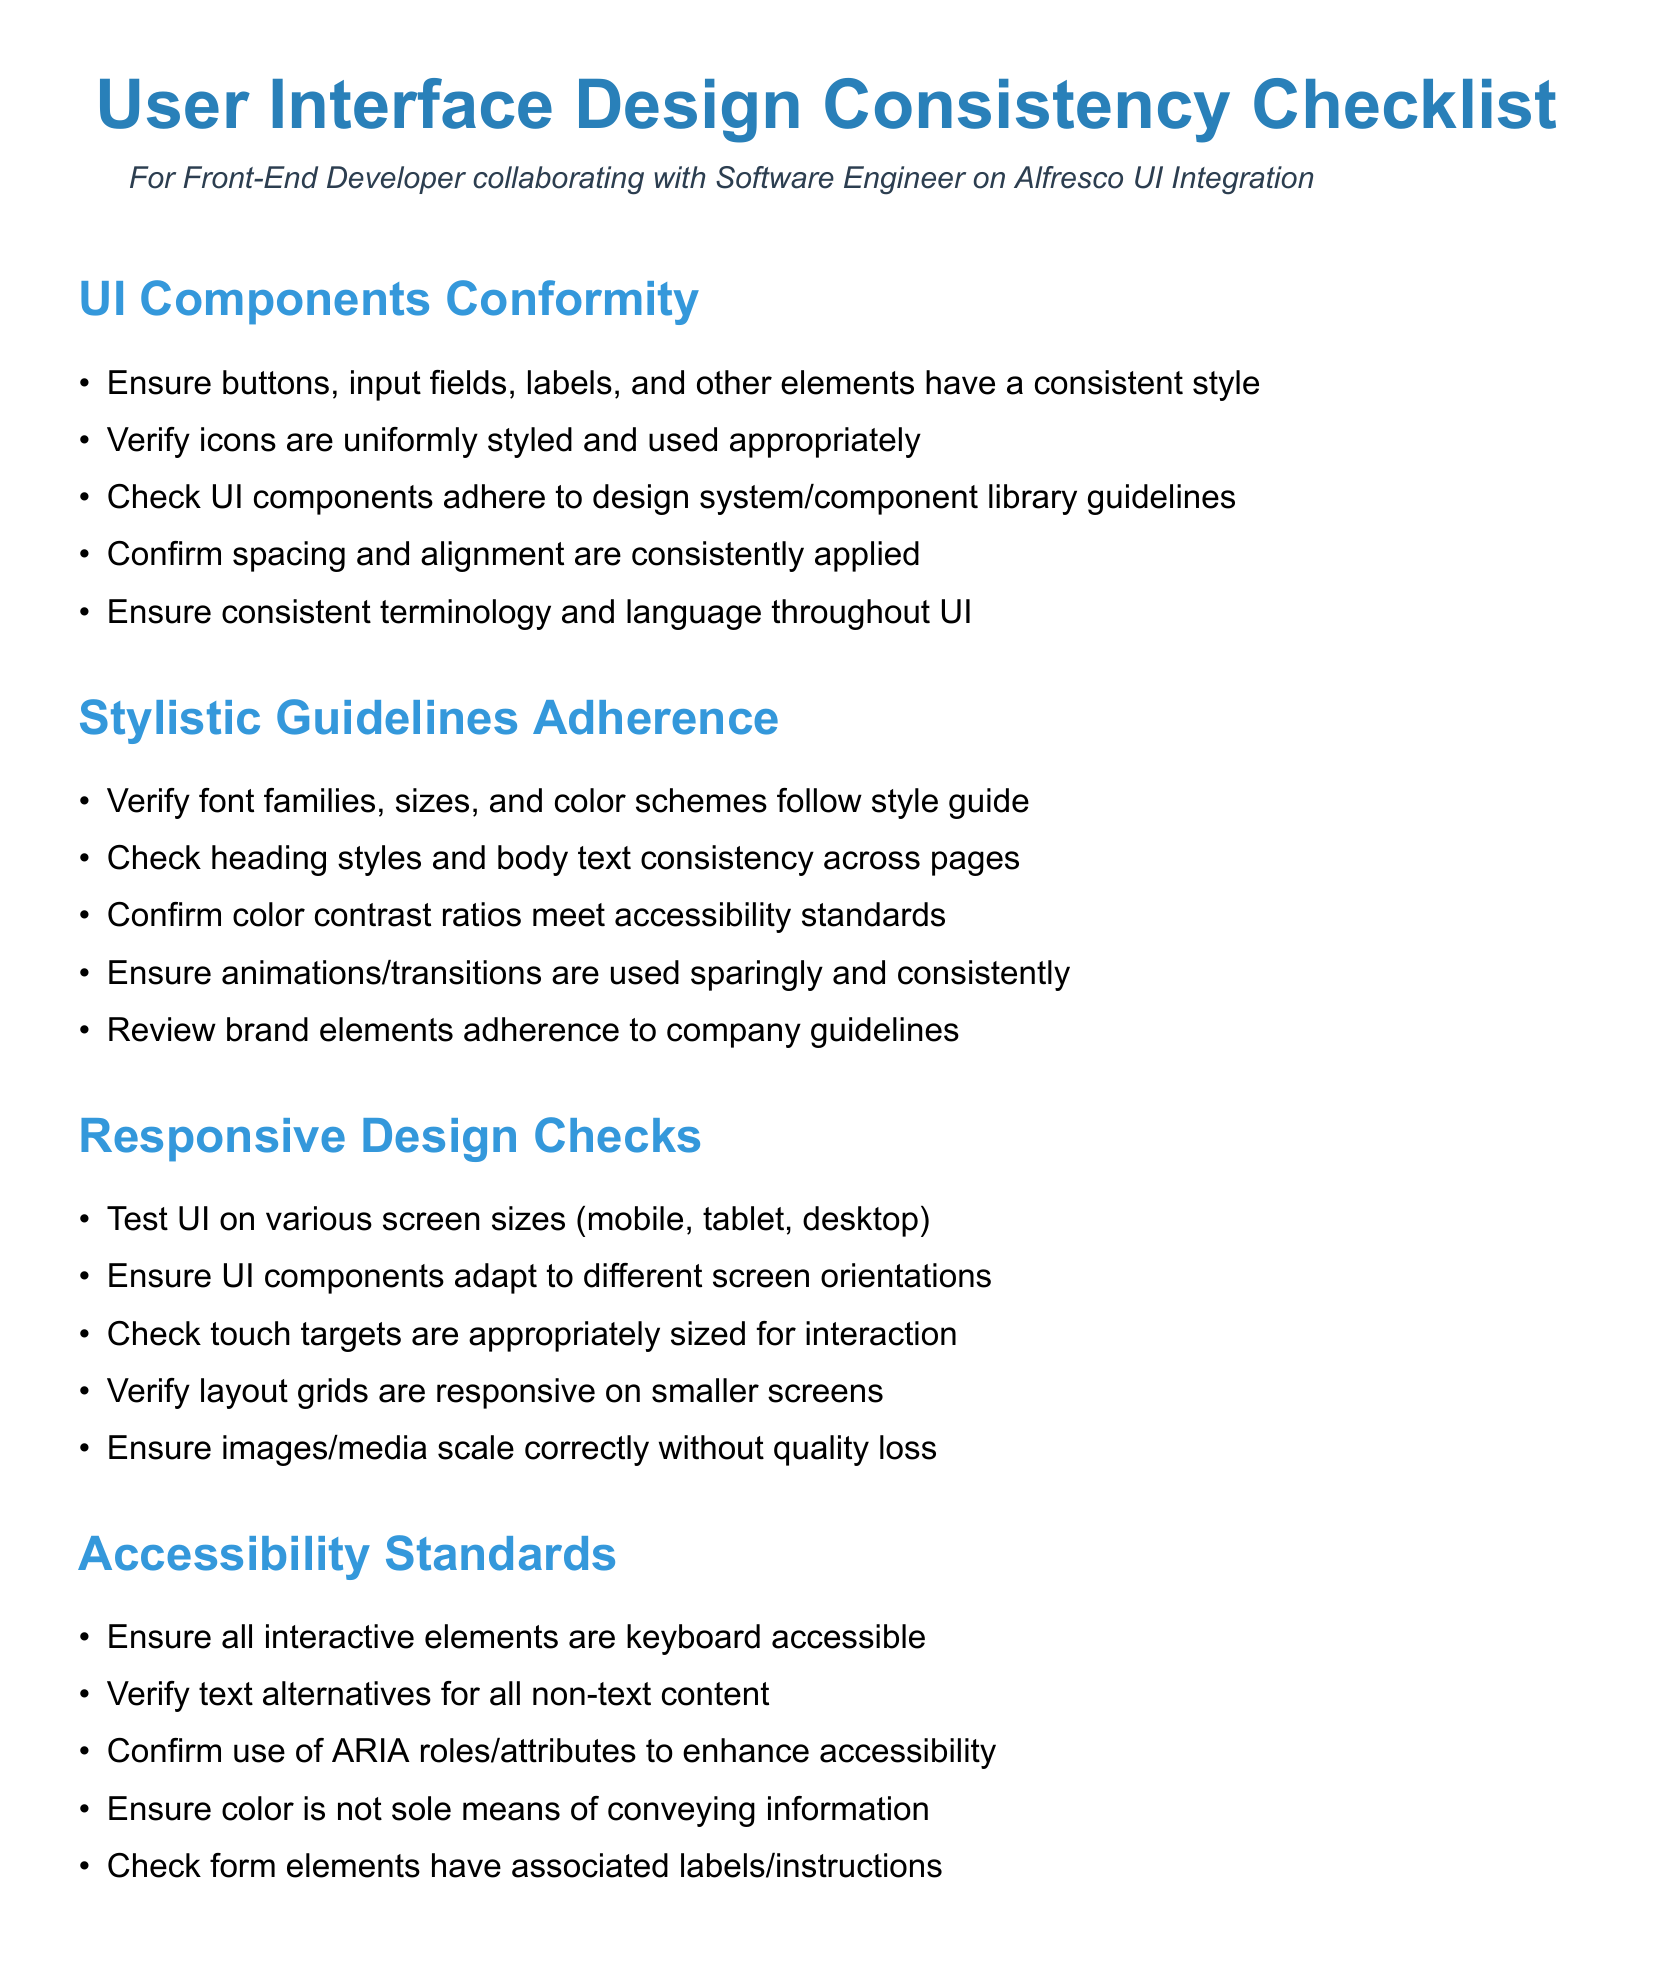What is the title of the document? The title of the document is stated at the beginning in a large font.
Answer: User Interface Design Consistency Checklist How many sections are in the checklist? The document includes four distinct sections, each addressing different aspects of UI design.
Answer: 4 What is the first item in the UI Components Conformity section? The first item listed under UI Components Conformity pertains to the style of various UI elements.
Answer: Ensure buttons, input fields, labels, and other elements have a consistent style What should be verified for non-text content? This refers to ensuring an alternative description accompanies non-text elements to aid accessibility.
Answer: Verify text alternatives for all non-text content What is the minimum requirement for color contrast ratios? This is a key point to comply with accessibility standards; the document specifies checking these ratios.
Answer: Confirm color contrast ratios meet accessibility standards How should UI components adapt according to the document? The document states that UI components should be responsive to various screen sizes and orientations.
Answer: Ensure UI components adapt to different screen orientations What does the document say about animations? The corresponding guideline emphasizes moderation and uniformity in animation usage across the UI.
Answer: Ensure animations/transitions are used sparingly and consistently What is one requirement for interactive elements? The document highlights that keyboard accessibility is a fundamental requirement for all interactive elements.
Answer: Ensure all interactive elements are keyboard accessible What is the suggested touch target size aspect? This guideline is intended to improve the usability of touch interactions on mobile devices.
Answer: Check touch targets are appropriately sized for interaction 